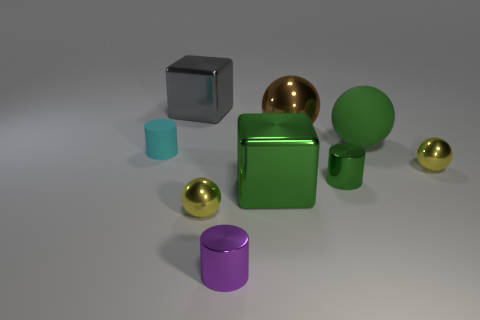Subtract all spheres. How many objects are left? 5 Subtract all small green cylinders. Subtract all gray shiny blocks. How many objects are left? 7 Add 8 small cyan things. How many small cyan things are left? 9 Add 7 large green rubber objects. How many large green rubber objects exist? 8 Subtract 1 cyan cylinders. How many objects are left? 8 